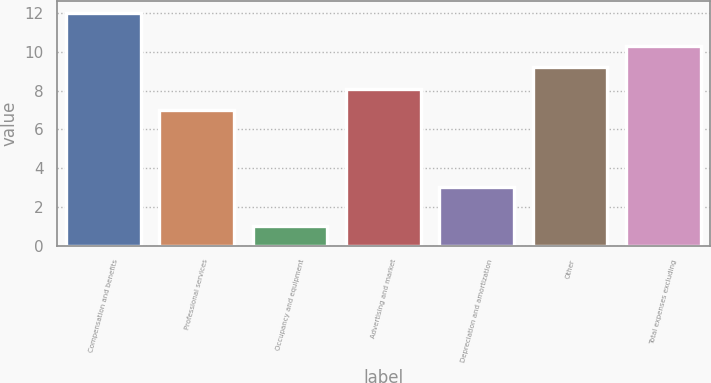Convert chart. <chart><loc_0><loc_0><loc_500><loc_500><bar_chart><fcel>Compensation and benefits<fcel>Professional services<fcel>Occupancy and equipment<fcel>Advertising and market<fcel>Depreciation and amortization<fcel>Other<fcel>Total expenses excluding<nl><fcel>12<fcel>7<fcel>1<fcel>8.1<fcel>3<fcel>9.2<fcel>10.3<nl></chart> 